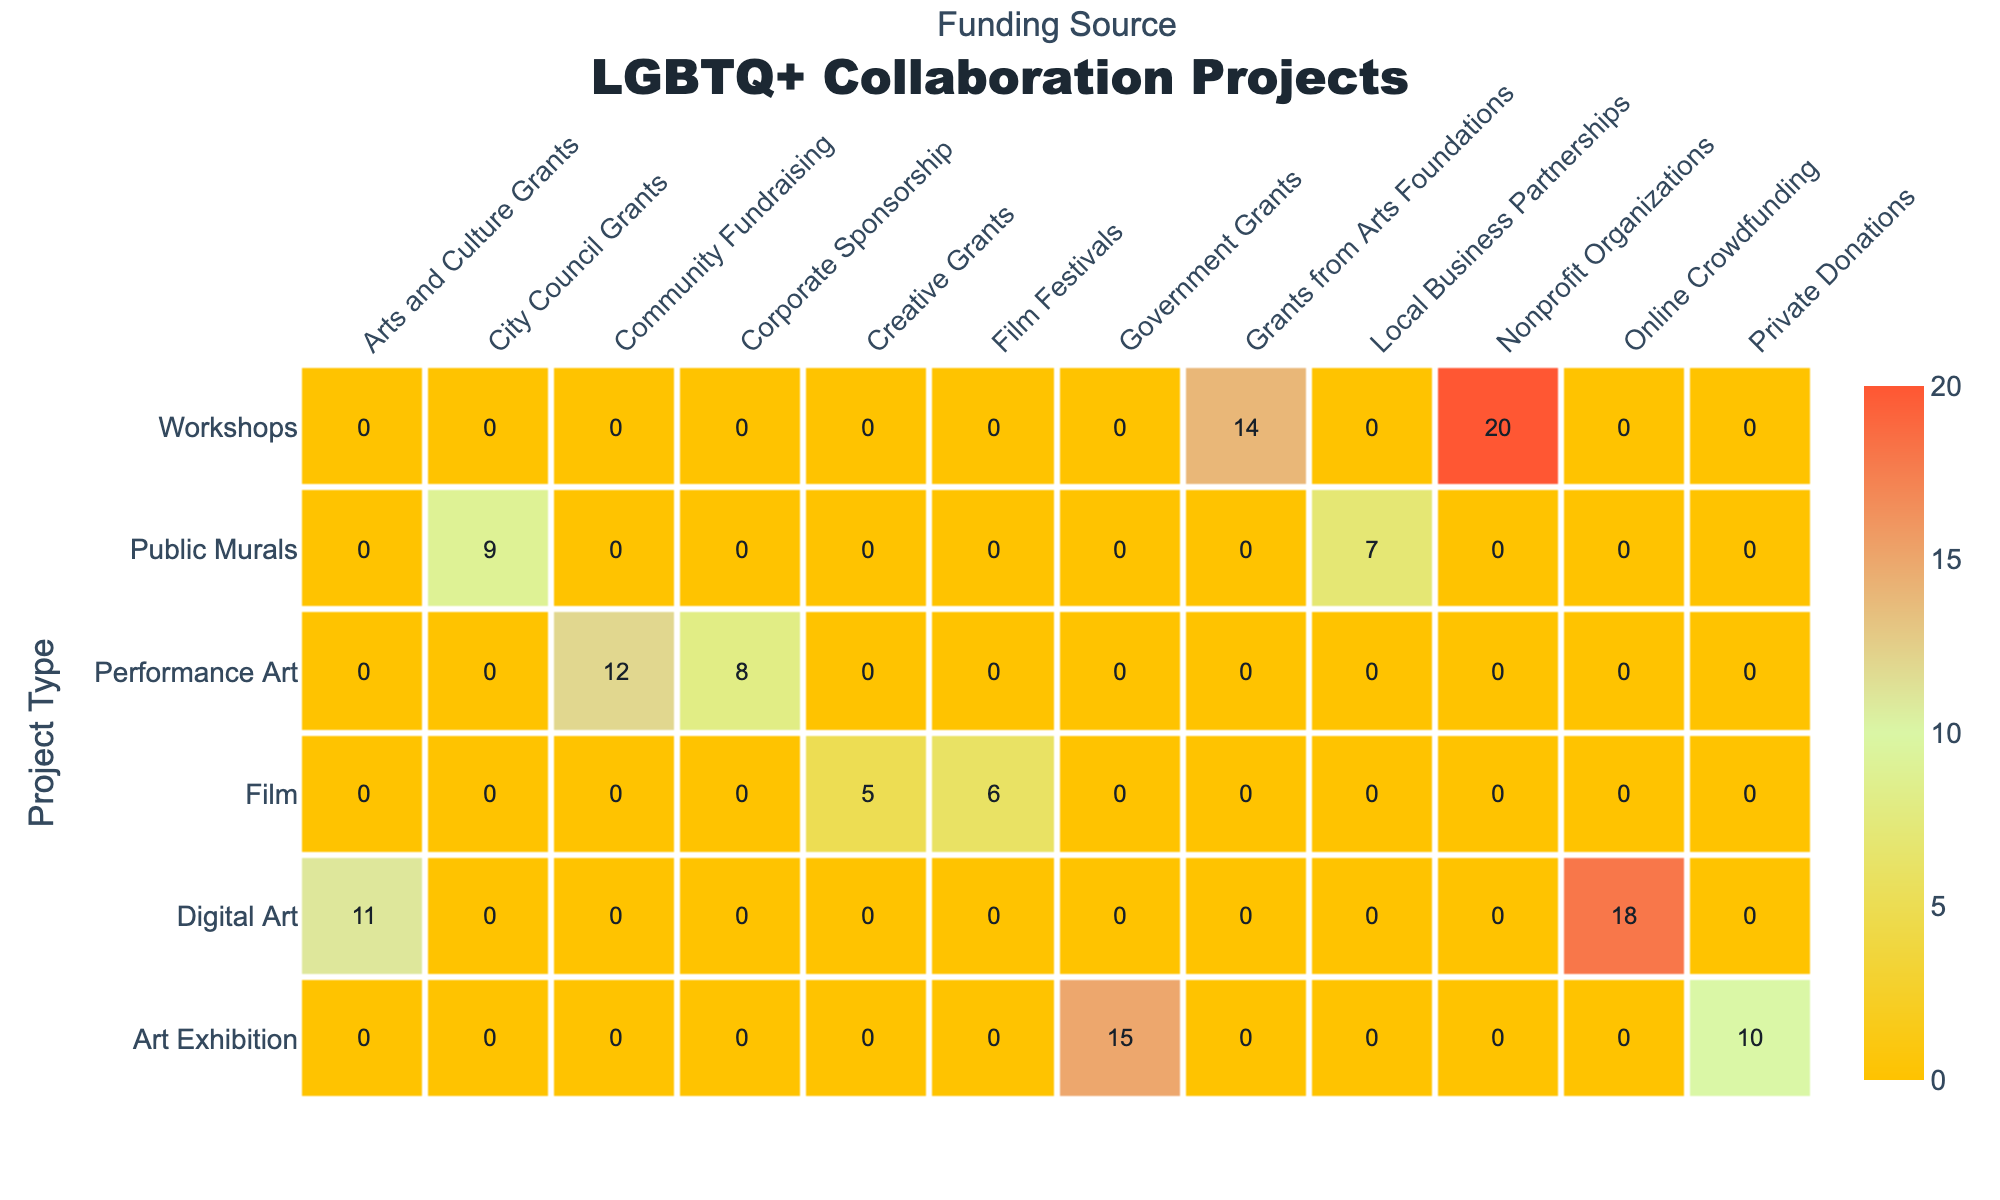What is the number of performance art projects funded by community fundraising? In the table, look for the row under "Performance Art" and find the column for "Community Fundraising." The corresponding value is 12, which indicates the number of projects funded this way.
Answer: 12 How many projects in total are funded by government grants? To find this, we examine the rows corresponding to each project type where the funding source is "Government Grants." The number of projects is 15 for Art Exhibition, and by checking there are no other project types funded by this source, we conclude the total is 15.
Answer: 15 Which project type has the highest number of projects in total? We need to sum the number of projects for each project type. For Art Exhibitions, it's 15 + 10 = 25; Performance Art: 12 + 8 = 20; Workshops: 20 + 14 = 34; Public Murals: 7 + 9 = 16; Digital Art: 18 + 11 = 29; Film: 6 + 5 = 11. The maximum sum is for Workshops, which totals 34.
Answer: Workshops Is there a project type that has more corporate sponsorship projects than performance art projects? Check the number of projects for Corporate Sponsorship, which is 8 for Performance Art. No other project type is listed under Corporate Sponsorship, making this a comparison only with itself. The statement is false, as there are no corporate sponsorship projects for any other types.
Answer: No What is the difference between the total number of digital art projects and the total number of workshop projects? Start by adding the digital art projects: 18 + 11 = 29. Next, do the same for workshops: 20 + 14 = 34. Now, calculate the difference: 34 - 29 = 5. Therefore, the total number of workshop projects exceeds digital art projects by 5.
Answer: 5 Which funding source has the least number of projects across all project types? Review the project counts for each funding source: City Council Grants (9), Local Business Partnerships (7), Corporate Sponsorship (8), Nonprofit Organizations (20), Grants from Arts Foundations (14), Arts and Culture Grants (11), Private Donations (10), Government Grants (15), Community Fundraising (12), and Creative Grants (5). The least is Creative Grants with 5 projects.
Answer: Creative Grants How many projects are funded by arts and culture grants and online crowdfunding combined? First, look up the values: 11 projects are under Arts and Culture Grants and 18 for Online Crowdfunding. Combine these two numbers: 11 + 18 = 29. Therefore, the total is 29 projects funded by these sources.
Answer: 29 Are there more art exhibition projects than public murals projects? Compare the totals: Art Exhibitions have 15 + 10 = 25 projects, while Public Murals total 7 + 9 = 16 projects. Since 25 is greater than 16, the statement is true.
Answer: Yes What is the average number of projects per project type? There are 6 project types counted, each with a different number of projects: 25 (Art Exhibitions), 20 (Performance Art), 34 (Workshops), 16 (Public Murals), 29 (Digital Art), and 11 (Film). Summing these up gives 25 + 20 + 34 + 16 + 29 + 11 = 135. Then divide 135 by the number of project types (6): 135 / 6 = 22.5.
Answer: 22.5 